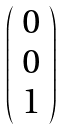Convert formula to latex. <formula><loc_0><loc_0><loc_500><loc_500>\left ( \begin{array} { c } 0 \\ 0 \\ 1 \end{array} \right )</formula> 